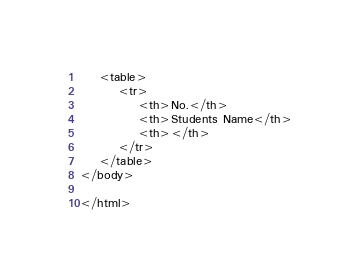<code> <loc_0><loc_0><loc_500><loc_500><_PHP_>    <table>
        <tr>
            <th>No.</th>
            <th>Students Name</th>
            <th></th>
        </tr>
    </table>
</body>

</html></code> 